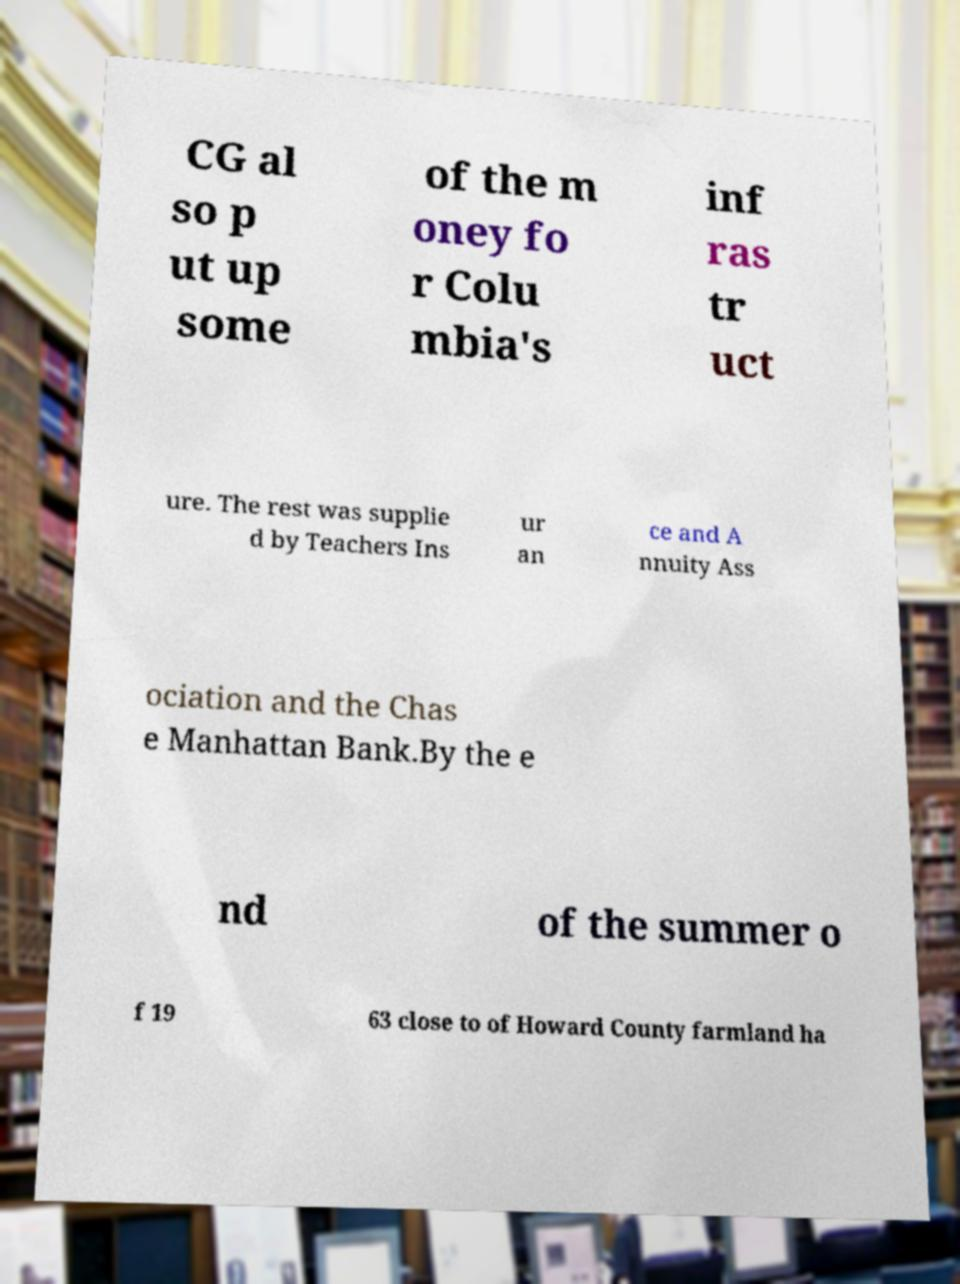Could you assist in decoding the text presented in this image and type it out clearly? CG al so p ut up some of the m oney fo r Colu mbia's inf ras tr uct ure. The rest was supplie d by Teachers Ins ur an ce and A nnuity Ass ociation and the Chas e Manhattan Bank.By the e nd of the summer o f 19 63 close to of Howard County farmland ha 